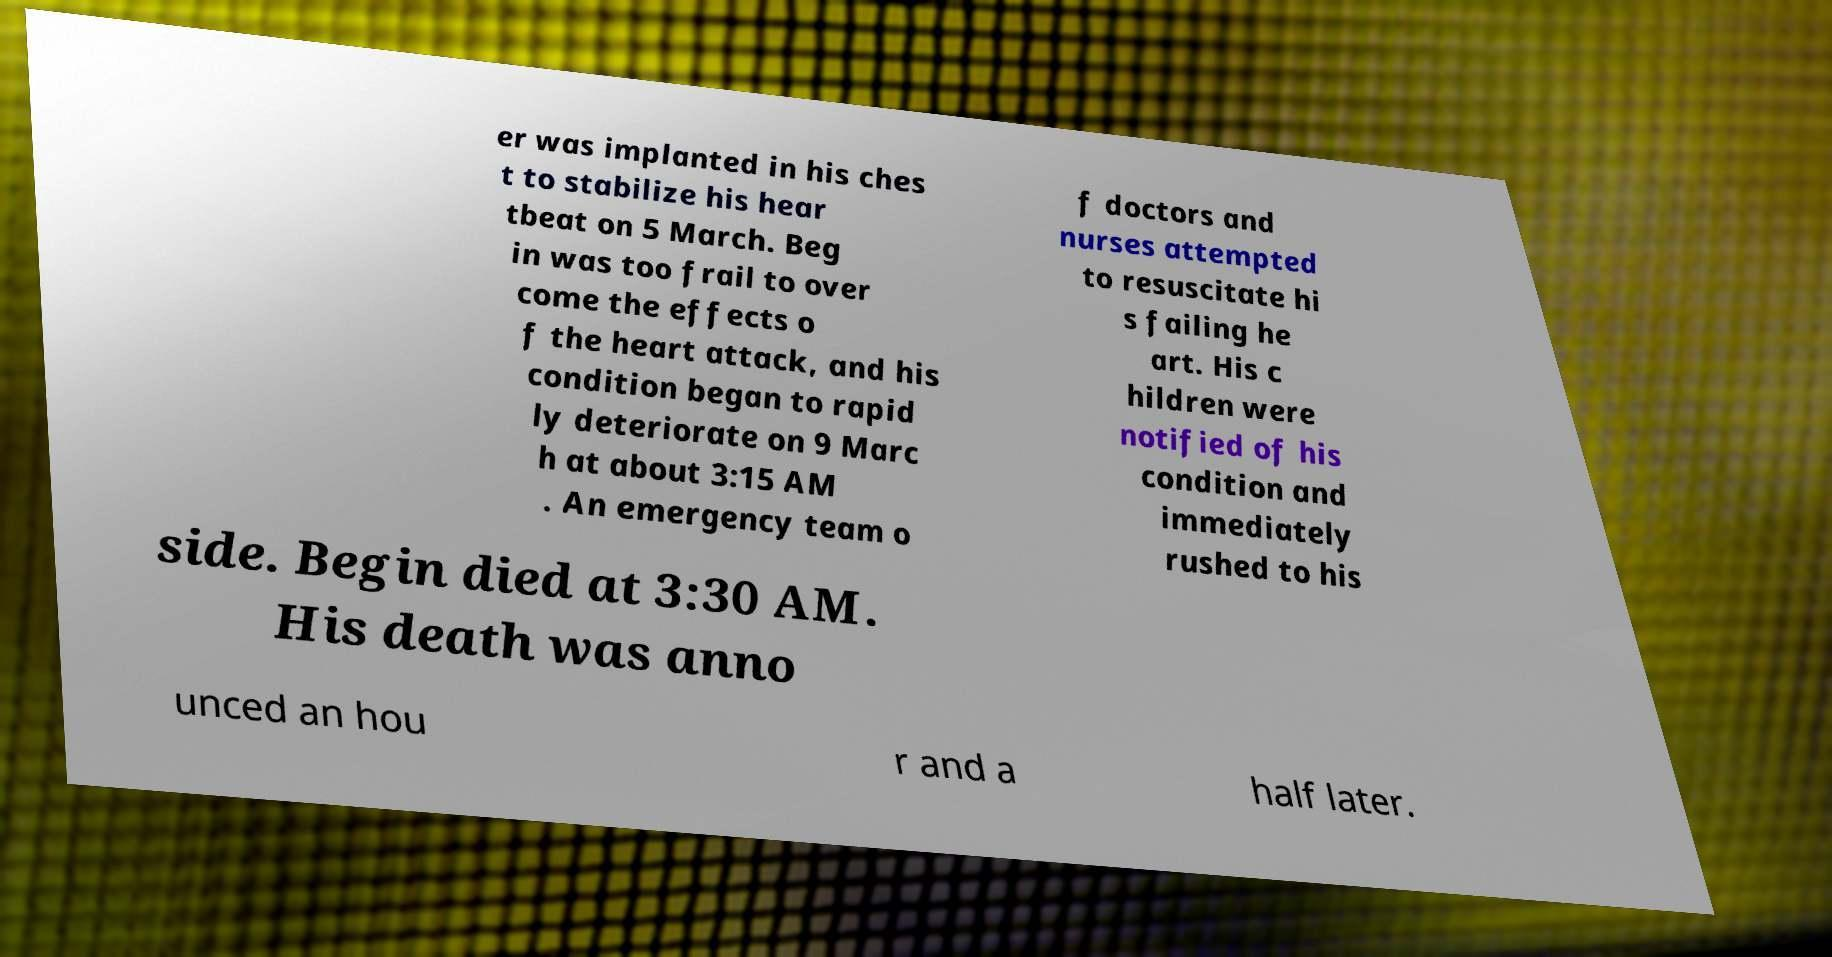There's text embedded in this image that I need extracted. Can you transcribe it verbatim? er was implanted in his ches t to stabilize his hear tbeat on 5 March. Beg in was too frail to over come the effects o f the heart attack, and his condition began to rapid ly deteriorate on 9 Marc h at about 3:15 AM . An emergency team o f doctors and nurses attempted to resuscitate hi s failing he art. His c hildren were notified of his condition and immediately rushed to his side. Begin died at 3:30 AM. His death was anno unced an hou r and a half later. 